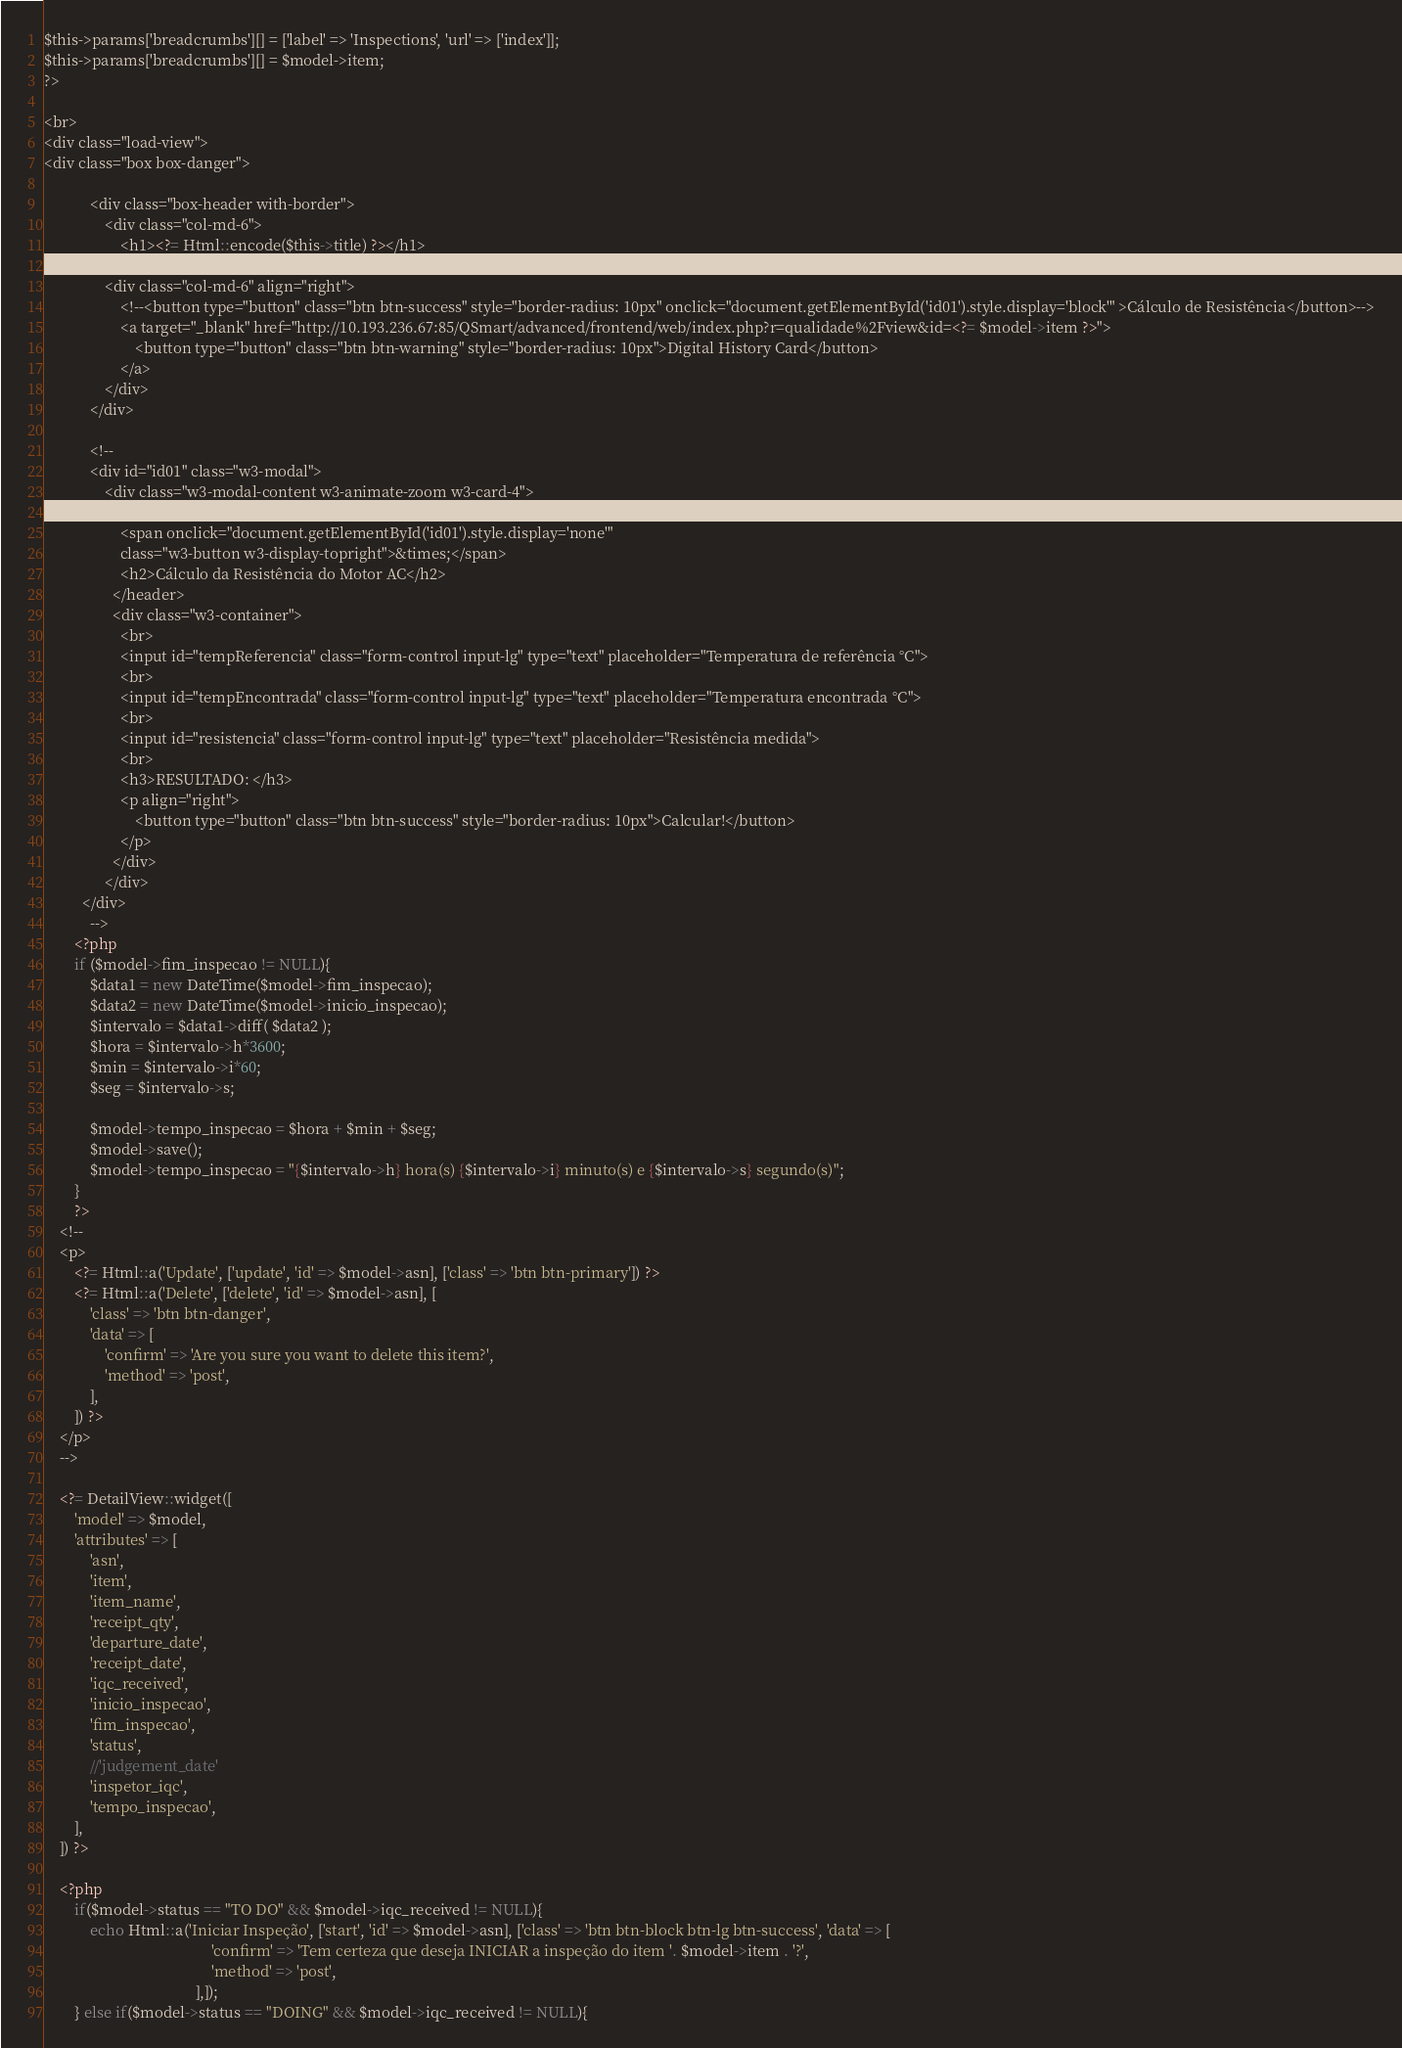Convert code to text. <code><loc_0><loc_0><loc_500><loc_500><_PHP_>$this->params['breadcrumbs'][] = ['label' => 'Inspections', 'url' => ['index']];
$this->params['breadcrumbs'][] = $model->item;
?>

<br>
<div class="load-view">
<div class="box box-danger">

            <div class="box-header with-border">
				<div class="col-md-6">
					<h1><?= Html::encode($this->title) ?></h1>
				</div>
				<div class="col-md-6" align="right">
					<!--<button type="button" class="btn btn-success" style="border-radius: 10px" onclick="document.getElementById('id01').style.display='block'" >Cálculo de Resistência</button>-->
					<a target="_blank" href="http://10.193.236.67:85/QSmart/advanced/frontend/web/index.php?r=qualidade%2Fview&id=<?= $model->item ?>">
						<button type="button" class="btn btn-warning" style="border-radius: 10px">Digital History Card</button>
					</a>
				</div>
			</div>
			
			<!--
			<div id="id01" class="w3-modal">
				<div class="w3-modal-content w3-animate-zoom w3-card-4">
				  <header class="w3-container w3-teal"> 
					<span onclick="document.getElementById('id01').style.display='none'" 
					class="w3-button w3-display-topright">&times;</span>
					<h2>Cálculo da Resistência do Motor AC</h2>
				  </header>
				  <div class="w3-container">
					<br>
					<input id="tempReferencia" class="form-control input-lg" type="text" placeholder="Temperatura de referência °C">
					<br>
					<input id="tempEncontrada" class="form-control input-lg" type="text" placeholder="Temperatura encontrada °C">
					<br>
					<input id="resistencia" class="form-control input-lg" type="text" placeholder="Resistência medida">
					<br>
					<h3>RESULTADO: </h3>
					<p align="right">
						<button type="button" class="btn btn-success" style="border-radius: 10px">Calcular!</button>
					</p>
				  </div>
				</div>
		  </div>
			-->
		<?php
		if ($model->fim_inspecao != NULL){
			$data1 = new DateTime($model->fim_inspecao);
			$data2 = new DateTime($model->inicio_inspecao);
			$intervalo = $data1->diff( $data2 );
			$hora = $intervalo->h*3600;
			$min = $intervalo->i*60;
			$seg = $intervalo->s;
			
			$model->tempo_inspecao = $hora + $min + $seg;
			$model->save();
			$model->tempo_inspecao = "{$intervalo->h} hora(s) {$intervalo->i} minuto(s) e {$intervalo->s} segundo(s)";
		}
		?>
    <!--
	<p>
        <?= Html::a('Update', ['update', 'id' => $model->asn], ['class' => 'btn btn-primary']) ?>
        <?= Html::a('Delete', ['delete', 'id' => $model->asn], [
            'class' => 'btn btn-danger',
            'data' => [
                'confirm' => 'Are you sure you want to delete this item?',
                'method' => 'post',
            ],
        ]) ?>
    </p>
	-->
	 
    <?= DetailView::widget([
        'model' => $model,
        'attributes' => [
            'asn',
            'item',
            'item_name',
            'receipt_qty',
            'departure_date',
            'receipt_date',
            'iqc_received',
            'inicio_inspecao',
            'fim_inspecao',
            'status',
			//'judgement_date'
            'inspetor_iqc',
			'tempo_inspecao',
        ],
    ]) ?>
	
	<?php
		if($model->status == "TO DO" && $model->iqc_received != NULL){
			echo Html::a('Iniciar Inspeção', ['start', 'id' => $model->asn], ['class' => 'btn btn-block btn-lg btn-success', 'data' => [
                                            'confirm' => 'Tem certeza que deseja INICIAR a inspeção do item '. $model->item . '?',
                                            'method' => 'post',
                                        ],]);
		} else if($model->status == "DOING" && $model->iqc_received != NULL){</code> 